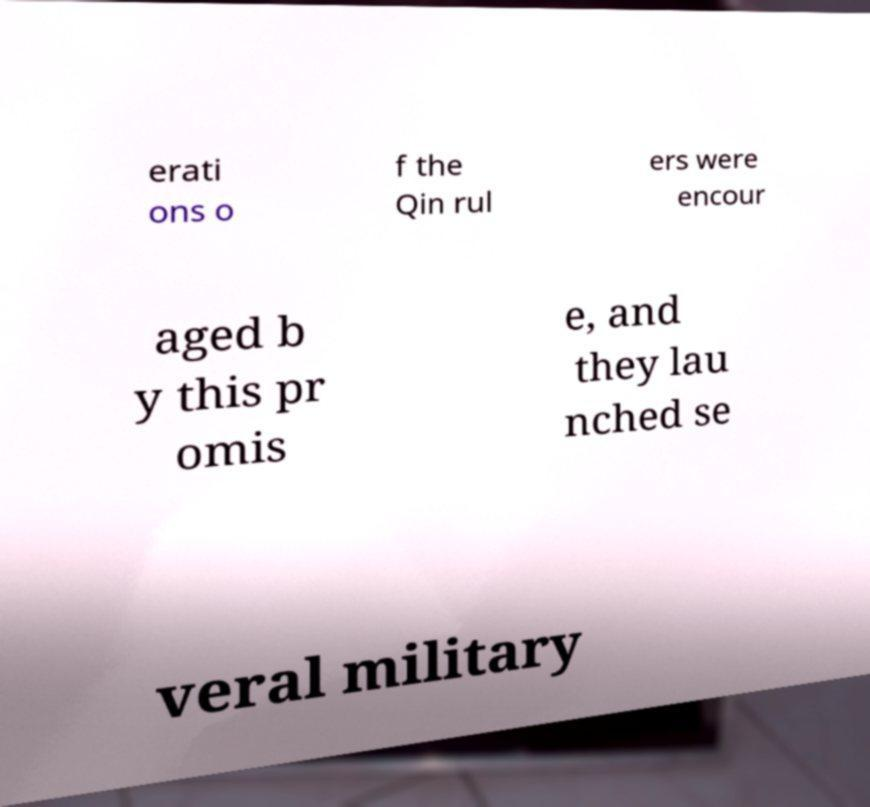Please read and relay the text visible in this image. What does it say? erati ons o f the Qin rul ers were encour aged b y this pr omis e, and they lau nched se veral military 